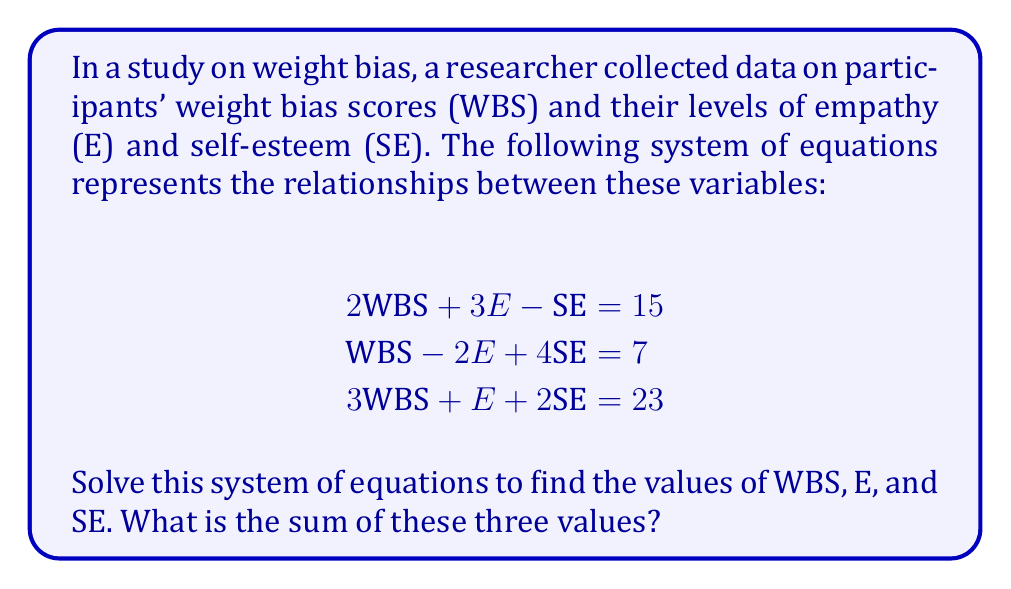Solve this math problem. Let's solve this system of equations using the elimination method:

Step 1: Multiply equation (1) by 3 and equation (2) by 2:
$$\begin{align}
6\text{WBS} + 9E - 3\text{SE} &= 45 \quad (4)\\
2\text{WBS} - 4E + 8\text{SE} &= 14 \quad (5)
\end{align}$$

Step 2: Add equations (4) and (5):
$$8\text{WBS} + 5E + 5\text{SE} = 59 \quad (6)$$

Step 3: Multiply equation (3) by -2 and add to equation (6):
$$2\text{WBS} + 3E + \text{SE} = 13 \quad (7)$$

Step 4: Subtract equation (1) from equation (7):
$$E + 2\text{SE} = -2 \quad (8)$$

Step 5: Multiply equation (8) by 2 and subtract from equation (2):
$$\text{WBS} + 3\text{SE} = 11 \quad (9)$$

Step 6: Multiply equation (8) by -1 and add to equation (3):
$$3\text{WBS} + \text{SE} = 25 \quad (10)$$

Step 7: Multiply equation (9) by 3 and subtract from equation (10):
$$8\text{WBS} = 42$$

Therefore, $\text{WBS} = \frac{21}{4} = 5.25$

Step 8: Substitute WBS into equation (9):
$$5.25 + 3\text{SE} = 11$$
$$3\text{SE} = 5.75$$
$$\text{SE} = \frac{5.75}{3} = 1.916667$$

Step 9: Substitute WBS and SE into equation (8):
$$E + 2(1.916667) = -2$$
$$E = -2 - 3.833334 = -5.833334$$

The sum of WBS, E, and SE is:
$$5.25 + (-5.833334) + 1.916667 = 1.333333$$
Answer: $1.333333$ 